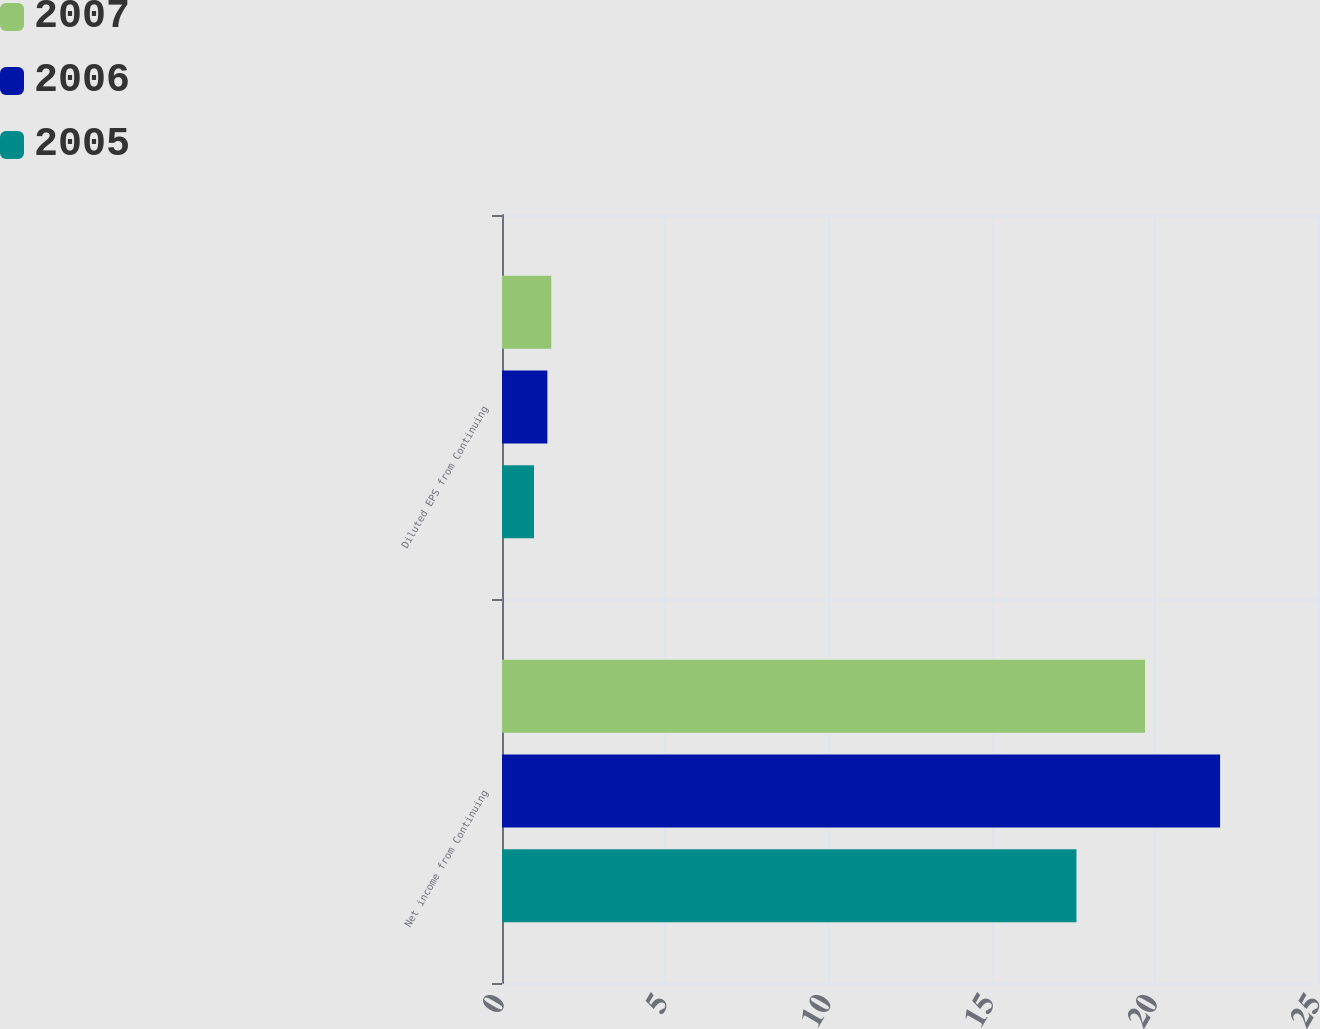Convert chart to OTSL. <chart><loc_0><loc_0><loc_500><loc_500><stacked_bar_chart><ecel><fcel>Net income from Continuing<fcel>Diluted EPS from Continuing<nl><fcel>2007<fcel>19.7<fcel>1.51<nl><fcel>2006<fcel>22<fcel>1.39<nl><fcel>2005<fcel>17.6<fcel>0.98<nl></chart> 